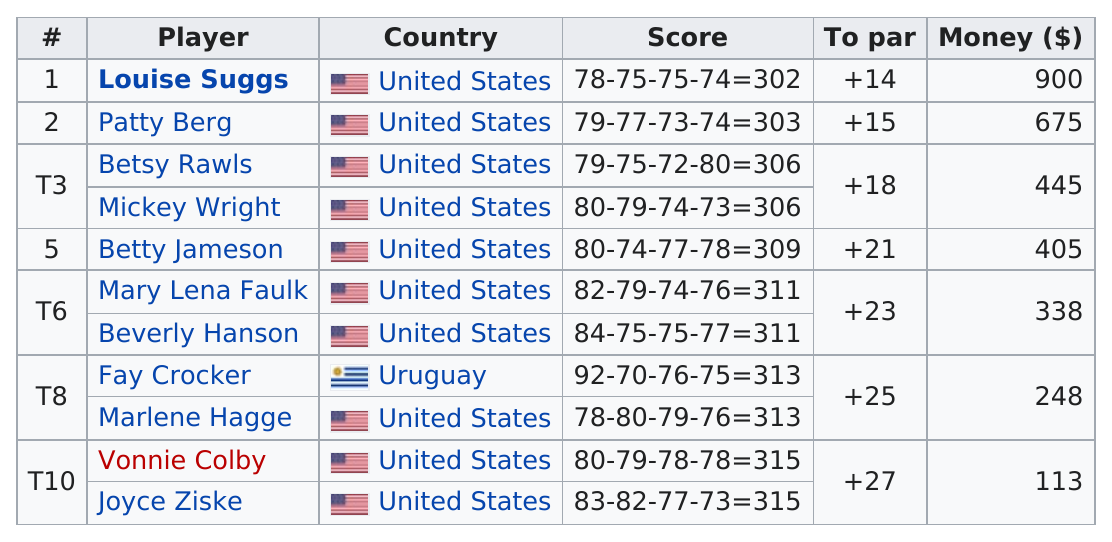Identify some key points in this picture. Louise Suggs won the most money. Fay Crocker was the only player listed from outside the United States. Out of the players who won at least $400, five of them won this amount. Out of the players with a score of an even number, how many have a score of 3? The difference between Betty Jameson and Patty Berg was 6. 